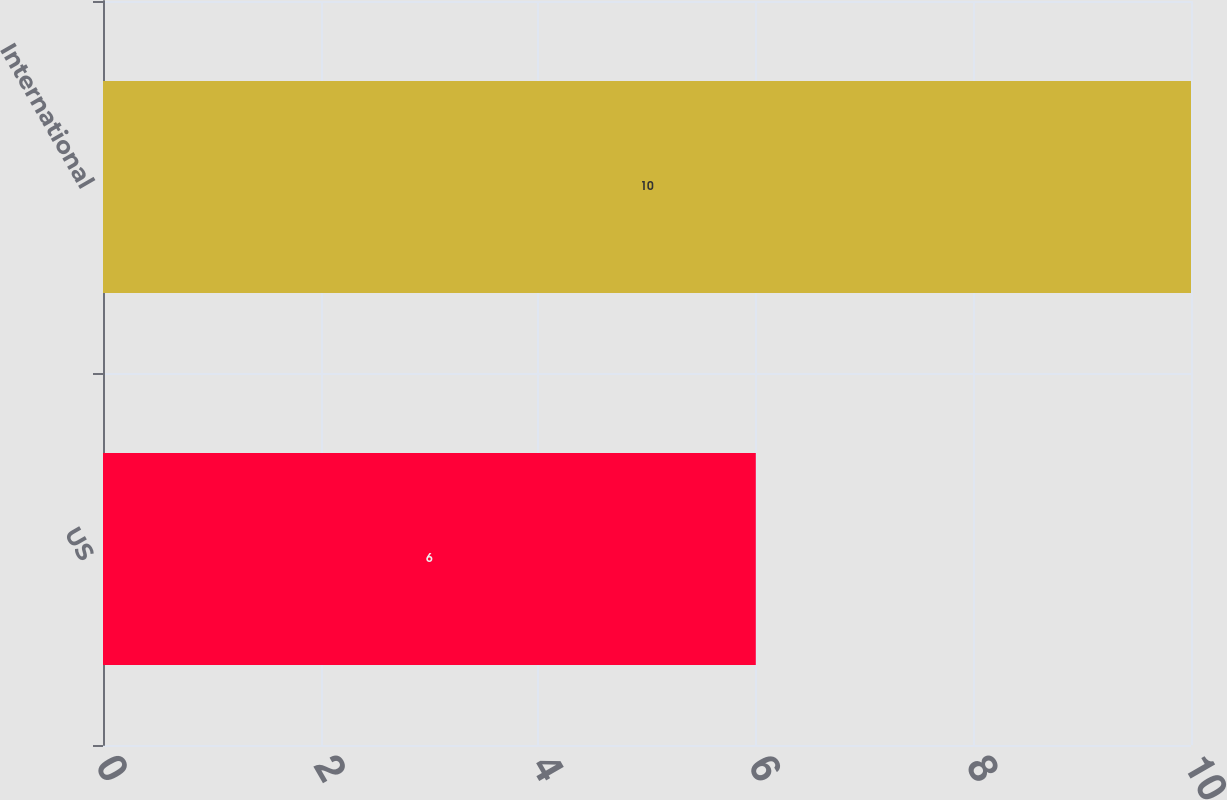Convert chart to OTSL. <chart><loc_0><loc_0><loc_500><loc_500><bar_chart><fcel>US<fcel>International<nl><fcel>6<fcel>10<nl></chart> 